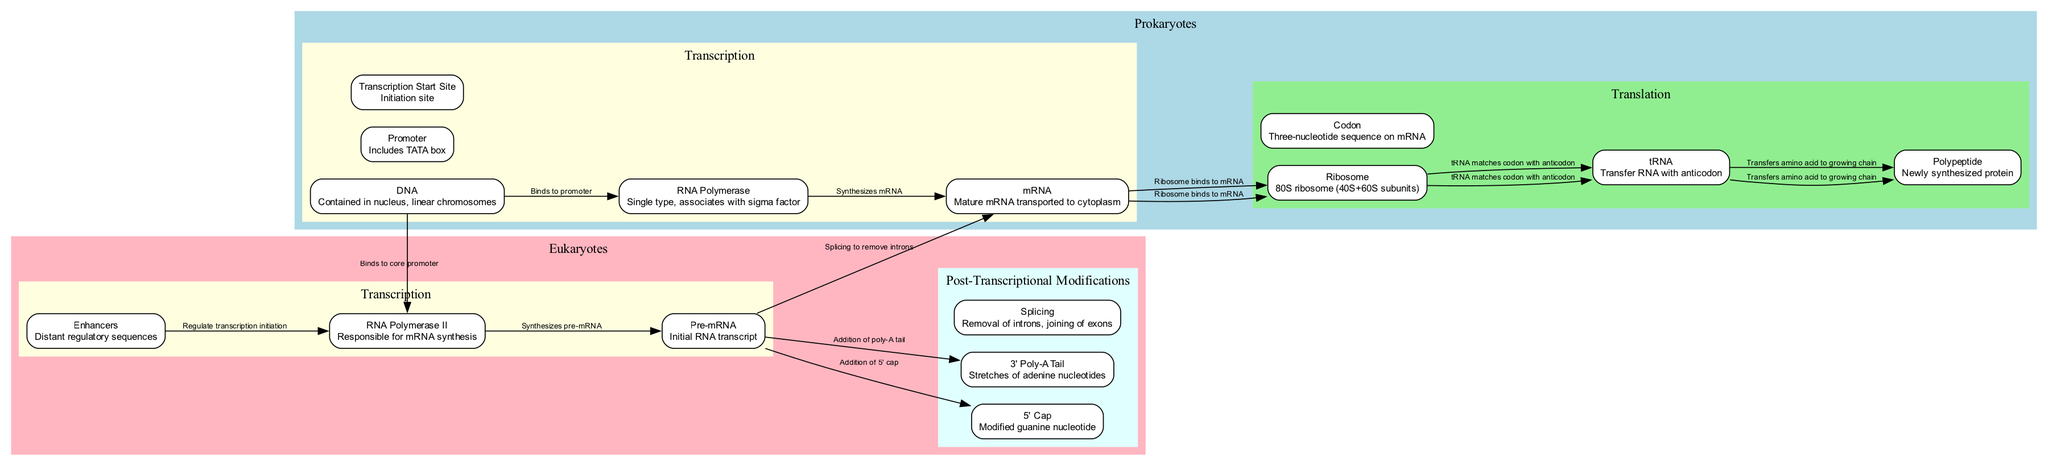What is the shape of the prokaryotic ribosome? The prokaryotic ribosome is identified in the diagram as a "70S ribosome" which consists of two subunits, 30S and 50S. This information is distinctly provided in the translation section for prokaryotes.
Answer: 70S ribosome How many types of RNA Polymerase are indicated in the diagram for prokaryotes? The diagram specifies "Single type" for prokaryotic RNA Polymerase, along with its association with a sigma factor, as described in the transcription section.
Answer: Single type What sequence is included in the prokaryote promoter? The prokaryotic promoter contains specific sequences, namely -10 (TATAAT) and -35 (TTGACA), which are provided in the transcription section of the prokaryote pathway.
Answer: -10 and -35 What does the term "Polycistronic" refer to in the prokaryotic mRNA? "Polycistronic" refers to mRNA that can encode multiple proteins, as noted in the description of the mRNA node under prokaryotic transcription.
Answer: Multiple proteins Which process immediately follows transcription in eukaryotic gene expression? In eukaryotic gene expression, the process that follows transcription is "Post-Transcriptional Modifications," as indicated by the flow and organization of the diagram.
Answer: Post-Transcriptional Modifications What is added to pre-mRNA during the post-transcriptional modifications phase? During post-transcriptional modifications, a "5' Cap" is added to pre-mRNA, as described in the elements and connections within that section.
Answer: 5' Cap How many nodes are there in the eukaryotic translation section? The eukaryotic translation section consists of five nodes, including mRNA, ribosome, tRNA, codon, and polypeptide, as counted from the listed elements in that subsection of the diagram.
Answer: Five What regulates transcription initiation in eukaryotes? "Enhancers" are described as the regulatory sequences that affect transcription initiation in eukaryotes, as shown in the edges of the transcription section.
Answer: Enhancers What type of RNA is synthesized by RNA Polymerase II in eukaryotic cells? The RNA Polymerase II synthesizes "Pre-mRNA," which is identified as the primary transcript in the eukaryotic transcription section of the diagram.
Answer: Pre-mRNA 